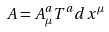<formula> <loc_0><loc_0><loc_500><loc_500>A = A _ { \mu } ^ { a } T ^ { a } d x ^ { \mu }</formula> 